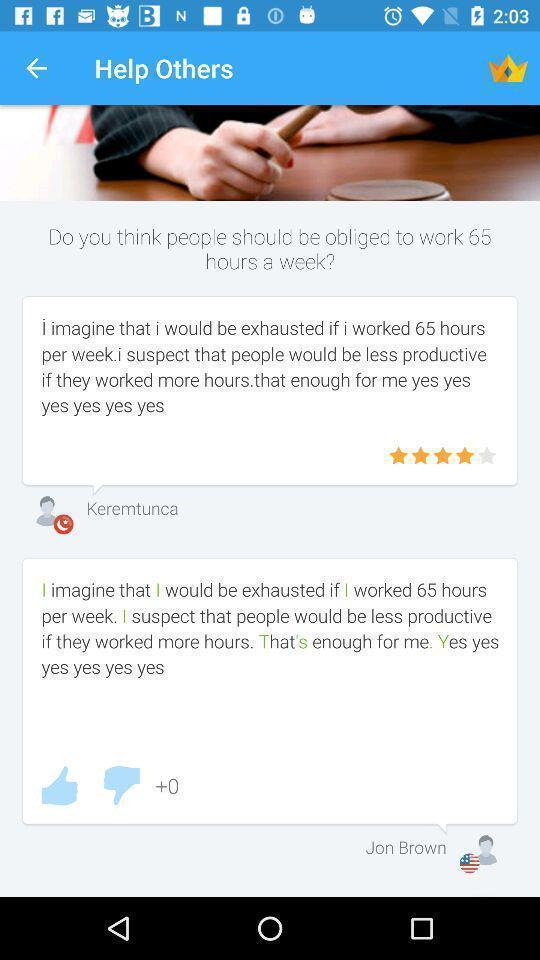Tell me about the visual elements in this screen capture. Screen shows help others with comments. 